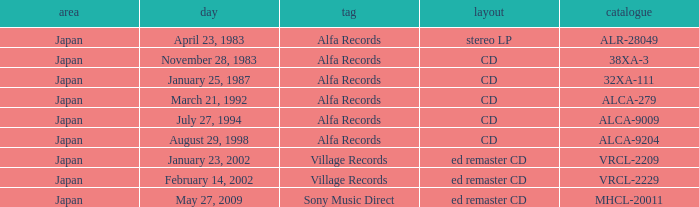Which label is dated February 14, 2002? Village Records. Could you parse the entire table as a dict? {'header': ['area', 'day', 'tag', 'layout', 'catalogue'], 'rows': [['Japan', 'April 23, 1983', 'Alfa Records', 'stereo LP', 'ALR-28049'], ['Japan', 'November 28, 1983', 'Alfa Records', 'CD', '38XA-3'], ['Japan', 'January 25, 1987', 'Alfa Records', 'CD', '32XA-111'], ['Japan', 'March 21, 1992', 'Alfa Records', 'CD', 'ALCA-279'], ['Japan', 'July 27, 1994', 'Alfa Records', 'CD', 'ALCA-9009'], ['Japan', 'August 29, 1998', 'Alfa Records', 'CD', 'ALCA-9204'], ['Japan', 'January 23, 2002', 'Village Records', 'ed remaster CD', 'VRCL-2209'], ['Japan', 'February 14, 2002', 'Village Records', 'ed remaster CD', 'VRCL-2229'], ['Japan', 'May 27, 2009', 'Sony Music Direct', 'ed remaster CD', 'MHCL-20011']]} 